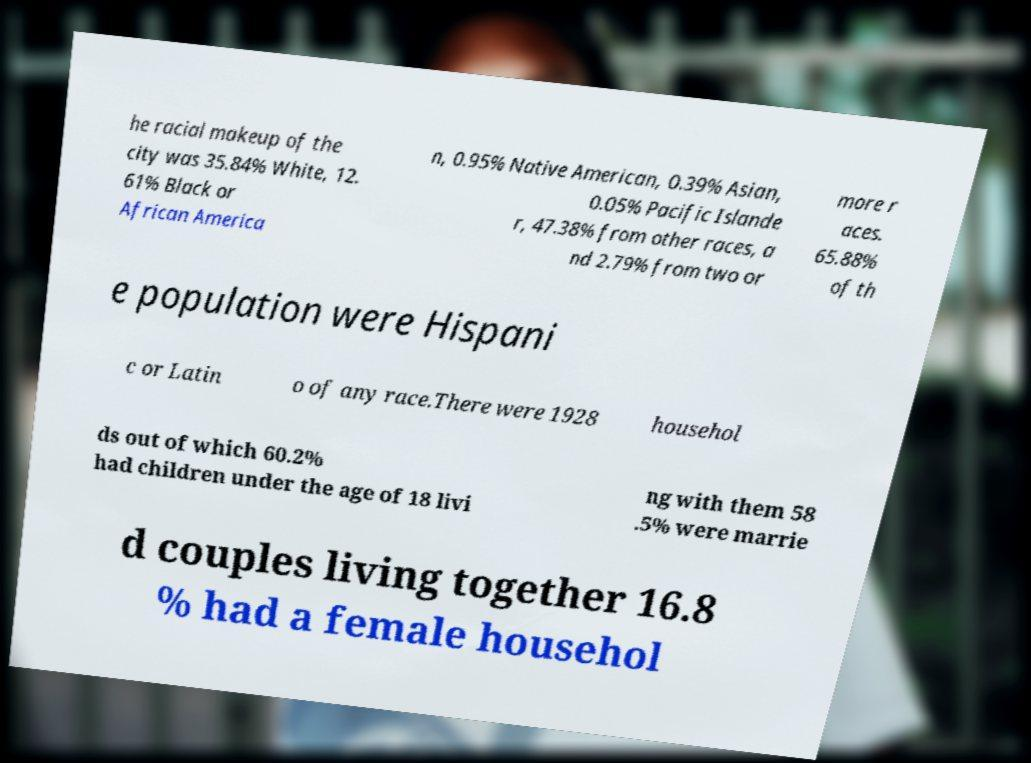Please identify and transcribe the text found in this image. he racial makeup of the city was 35.84% White, 12. 61% Black or African America n, 0.95% Native American, 0.39% Asian, 0.05% Pacific Islande r, 47.38% from other races, a nd 2.79% from two or more r aces. 65.88% of th e population were Hispani c or Latin o of any race.There were 1928 househol ds out of which 60.2% had children under the age of 18 livi ng with them 58 .5% were marrie d couples living together 16.8 % had a female househol 